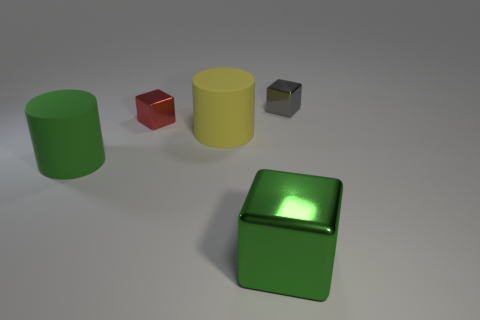Can you tell me about the shapes of the objects in the image? Certainly, the image displays objects with simple geometric shapes. There's a cylindrical green object, a small red cube, a larger yellow cylinder, and what appears to be a green metallic object with a shape that resembles a box with a slightly curved top. Each object has distinct surfaces reflecting the light differently, indicating their different textures. 